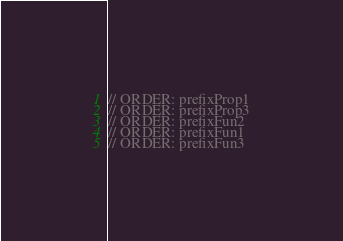<code> <loc_0><loc_0><loc_500><loc_500><_Kotlin_>// ORDER: prefixProp1
// ORDER: prefixProp3
// ORDER: prefixFun2
// ORDER: prefixFun1
// ORDER: prefixFun3
</code> 